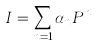<formula> <loc_0><loc_0><loc_500><loc_500>I = \sum _ { n = 1 } \alpha _ { n } P ^ { n }</formula> 